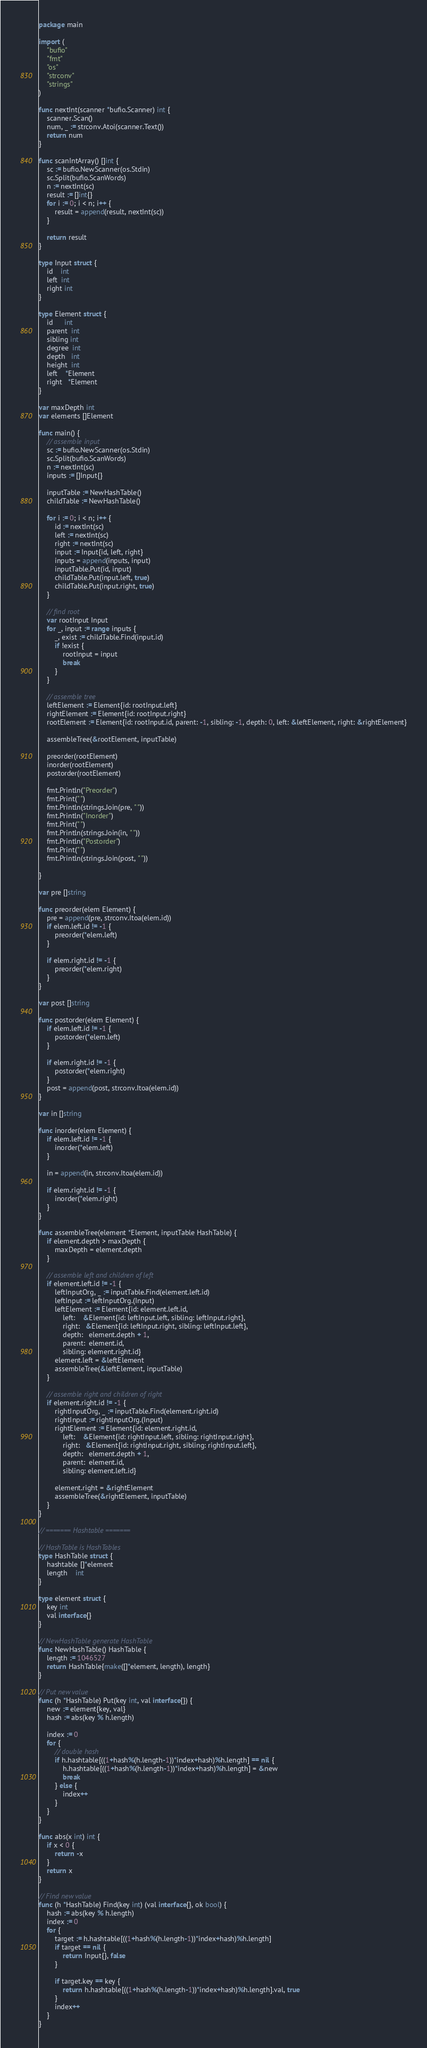Convert code to text. <code><loc_0><loc_0><loc_500><loc_500><_Go_>package main

import (
	"bufio"
	"fmt"
	"os"
	"strconv"
	"strings"
)

func nextInt(scanner *bufio.Scanner) int {
	scanner.Scan()
	num, _ := strconv.Atoi(scanner.Text())
	return num
}

func scanIntArray() []int {
	sc := bufio.NewScanner(os.Stdin)
	sc.Split(bufio.ScanWords)
	n := nextInt(sc)
	result := []int{}
	for i := 0; i < n; i++ {
		result = append(result, nextInt(sc))
	}

	return result
}

type Input struct {
	id    int
	left  int
	right int
}

type Element struct {
	id      int
	parent  int
	sibling int
	degree  int
	depth   int
	height  int
	left    *Element
	right   *Element
}

var maxDepth int
var elements []Element

func main() {
	// assemble input
	sc := bufio.NewScanner(os.Stdin)
	sc.Split(bufio.ScanWords)
	n := nextInt(sc)
	inputs := []Input{}

	inputTable := NewHashTable()
	childTable := NewHashTable()

	for i := 0; i < n; i++ {
		id := nextInt(sc)
		left := nextInt(sc)
		right := nextInt(sc)
		input := Input{id, left, right}
		inputs = append(inputs, input)
		inputTable.Put(id, input)
		childTable.Put(input.left, true)
		childTable.Put(input.right, true)
	}

	// find root
	var rootInput Input
	for _, input := range inputs {
		_, exist := childTable.Find(input.id)
		if !exist {
			rootInput = input
			break
		}
	}

	// assemble tree
	leftElement := Element{id: rootInput.left}
	rightElement := Element{id: rootInput.right}
	rootElement := Element{id: rootInput.id, parent: -1, sibling: -1, depth: 0, left: &leftElement, right: &rightElement}

	assembleTree(&rootElement, inputTable)

	preorder(rootElement)
	inorder(rootElement)
	postorder(rootElement)

	fmt.Println("Preorder")
	fmt.Print(" ")
	fmt.Println(strings.Join(pre, " "))
	fmt.Println("Inorder")
	fmt.Print(" ")
	fmt.Println(strings.Join(in, " "))
	fmt.Println("Postorder")
	fmt.Print(" ")
	fmt.Println(strings.Join(post, " "))

}

var pre []string

func preorder(elem Element) {
	pre = append(pre, strconv.Itoa(elem.id))
	if elem.left.id != -1 {
		preorder(*elem.left)
	}

	if elem.right.id != -1 {
		preorder(*elem.right)
	}
}

var post []string

func postorder(elem Element) {
	if elem.left.id != -1 {
		postorder(*elem.left)
	}

	if elem.right.id != -1 {
		postorder(*elem.right)
	}
	post = append(post, strconv.Itoa(elem.id))
}

var in []string

func inorder(elem Element) {
	if elem.left.id != -1 {
		inorder(*elem.left)
	}

	in = append(in, strconv.Itoa(elem.id))

	if elem.right.id != -1 {
		inorder(*elem.right)
	}
}

func assembleTree(element *Element, inputTable HashTable) {
	if element.depth > maxDepth {
		maxDepth = element.depth
	}

	// assemble left and children of left
	if element.left.id != -1 {
		leftInputOrg, _ := inputTable.Find(element.left.id)
		leftInput := leftInputOrg.(Input)
		leftElement := Element{id: element.left.id,
			left:    &Element{id: leftInput.left, sibling: leftInput.right},
			right:   &Element{id: leftInput.right, sibling: leftInput.left},
			depth:   element.depth + 1,
			parent:  element.id,
			sibling: element.right.id}
		element.left = &leftElement
		assembleTree(&leftElement, inputTable)
	}

	// assemble right and children of right
	if element.right.id != -1 {
		rightInputOrg, _ := inputTable.Find(element.right.id)
		rightInput := rightInputOrg.(Input)
		rightElement := Element{id: element.right.id,
			left:    &Element{id: rightInput.left, sibling: rightInput.right},
			right:   &Element{id: rightInput.right, sibling: rightInput.left},
			depth:   element.depth + 1,
			parent:  element.id,
			sibling: element.left.id}

		element.right = &rightElement
		assembleTree(&rightElement, inputTable)
	}
}

// ======= Hashtable =======

// HashTable is HashTables
type HashTable struct {
	hashtable []*element
	length    int
}

type element struct {
	key int
	val interface{}
}

// NewHashTable generate HashTable
func NewHashTable() HashTable {
	length := 1046527
	return HashTable{make([]*element, length), length}
}

// Put new value
func (h *HashTable) Put(key int, val interface{}) {
	new := element{key, val}
	hash := abs(key % h.length)

	index := 0
	for {
		// double hash
		if h.hashtable[((1+hash%(h.length-1))*index+hash)%h.length] == nil {
			h.hashtable[((1+hash%(h.length-1))*index+hash)%h.length] = &new
			break
		} else {
			index++
		}
	}
}

func abs(x int) int {
	if x < 0 {
		return -x
	}
	return x
}

// Find new value
func (h *HashTable) Find(key int) (val interface{}, ok bool) {
	hash := abs(key % h.length)
	index := 0
	for {
		target := h.hashtable[((1+hash%(h.length-1))*index+hash)%h.length]
		if target == nil {
			return Input{}, false
		}

		if target.key == key {
			return h.hashtable[((1+hash%(h.length-1))*index+hash)%h.length].val, true
		}
		index++
	}
}

</code> 